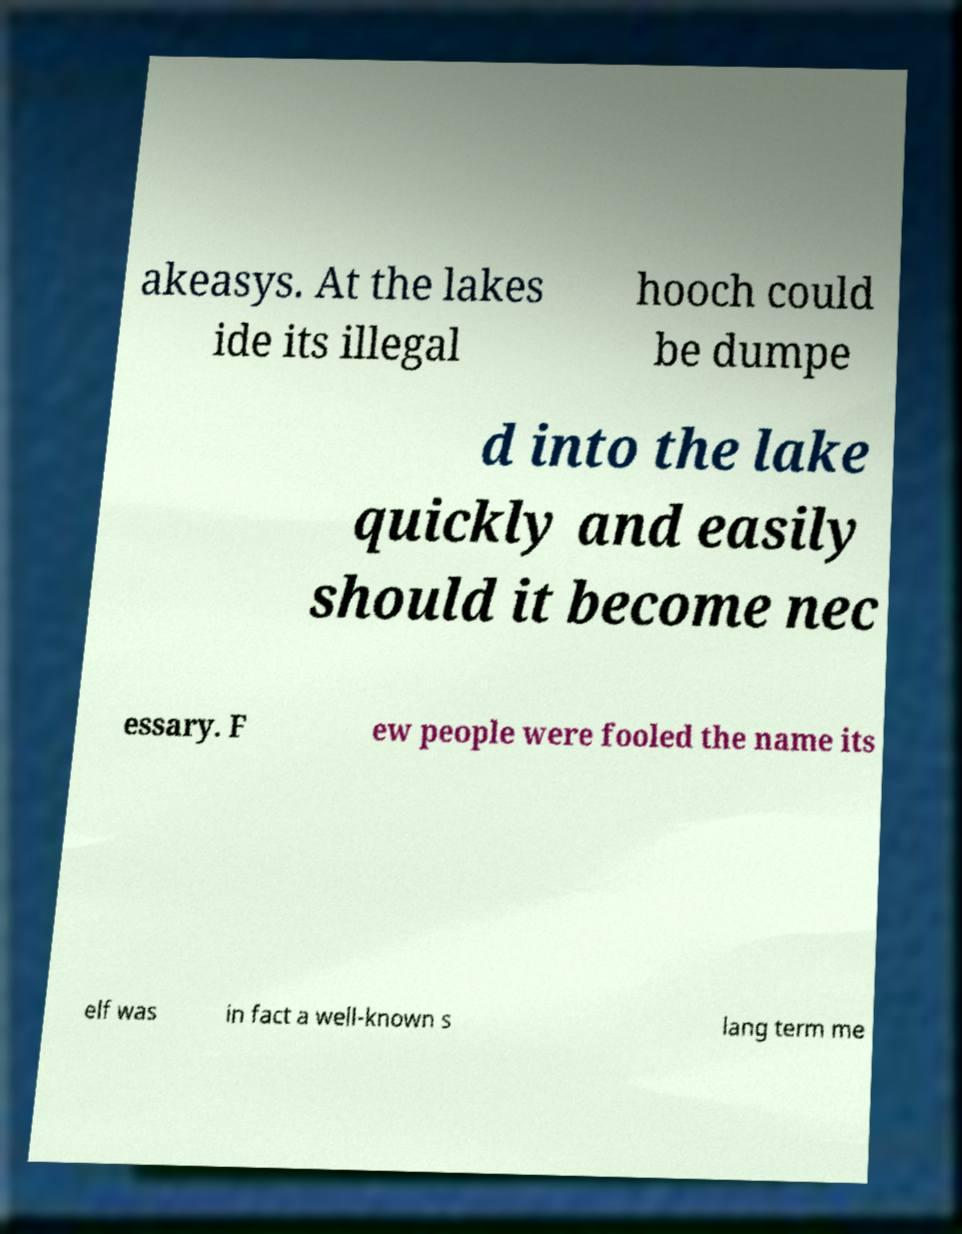Could you assist in decoding the text presented in this image and type it out clearly? akeasys. At the lakes ide its illegal hooch could be dumpe d into the lake quickly and easily should it become nec essary. F ew people were fooled the name its elf was in fact a well-known s lang term me 